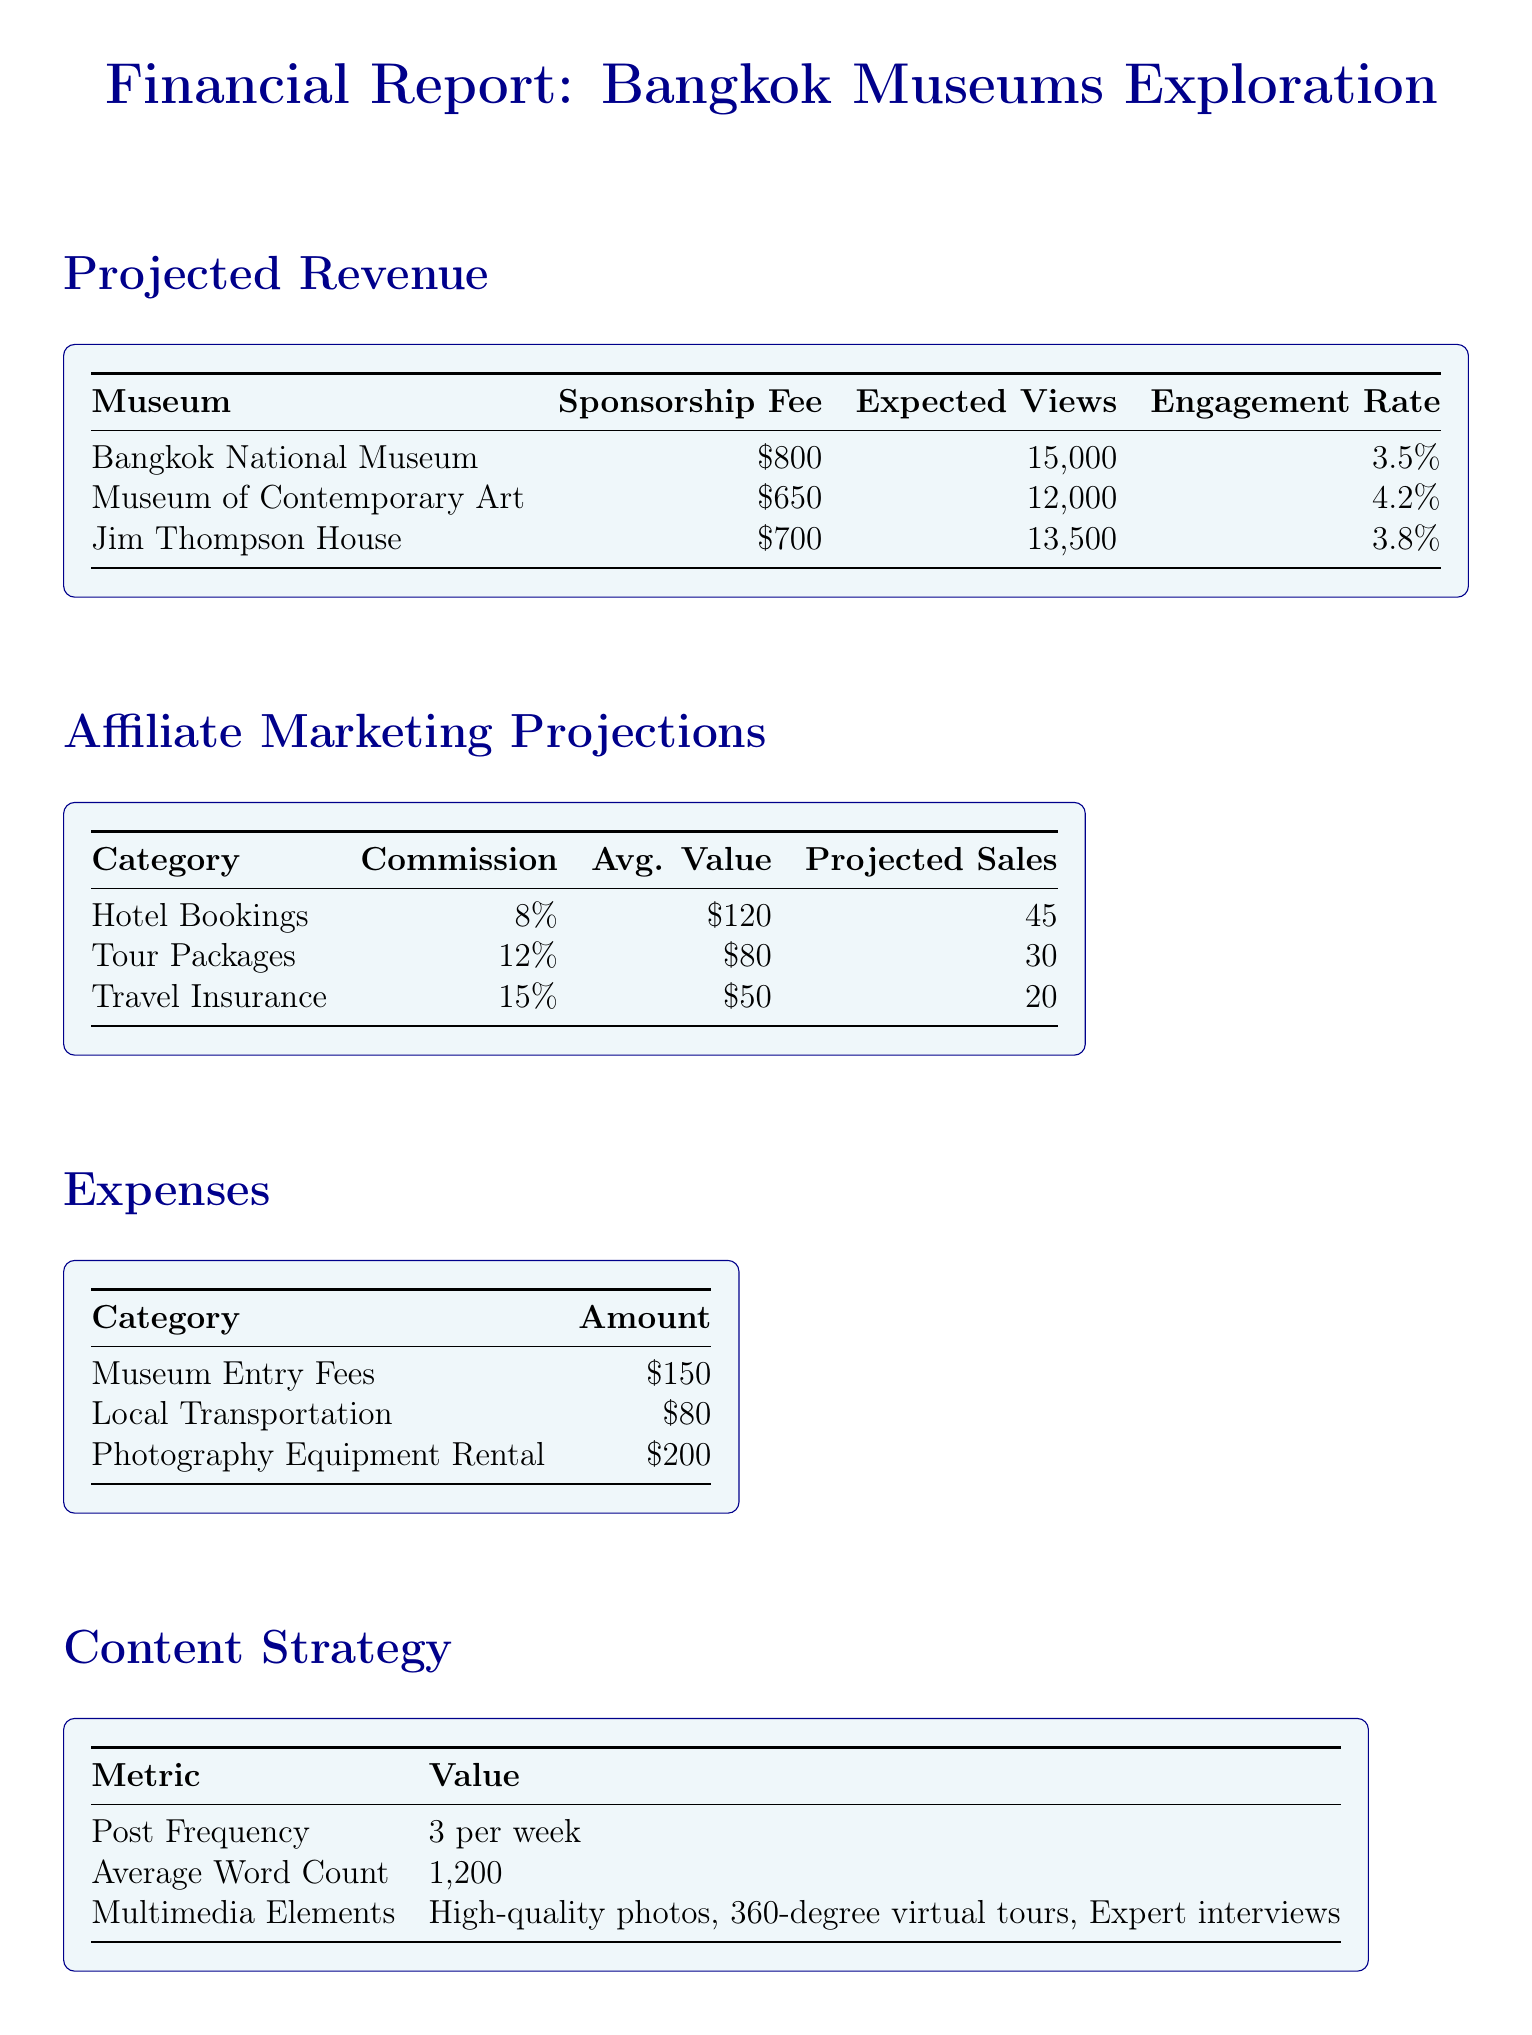What is the sponsorship fee for the Bangkok National Museum? The document lists the sponsorship fee for the Bangkok National Museum as $800.
Answer: $800 What is the expected engagement rate for the Museum of Contemporary Art? The document states that the expected engagement rate for the Museum of Contemporary Art is 4.2%.
Answer: 4.2% How many projected bookings are there for hotel bookings? The projected bookings for hotel bookings are mentioned as 45 in the affiliate marketing section.
Answer: 45 What is the total amount allocated for museum entry fees and local transportation? The total amount is the sum of museum entry fees ($150) and local transportation ($80), which equals $230.
Answer: $230 Which category has the highest estimated commission? The document indicates that travel insurance has the highest estimated commission at 15%.
Answer: 15% What is the average word count for blog posts? The average word count for blog posts is specified as 1200 words in the content strategy section.
Answer: 1200 What is the primary age group of the audience? The primary age group of the audience is identified as 25-34 years old.
Answer: 25-34 How many multimedia elements are in the content strategy? The content strategy lists three types of multimedia elements: high-quality photos, 360-degree virtual tours, and expert interviews.
Answer: 3 